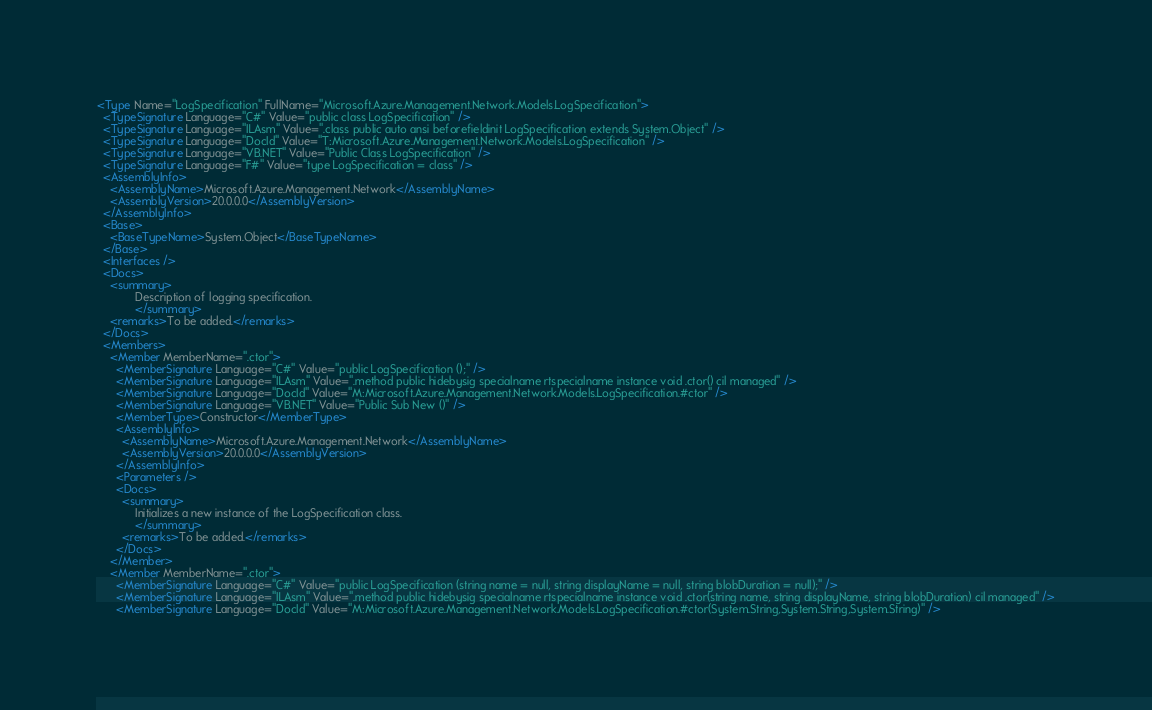<code> <loc_0><loc_0><loc_500><loc_500><_XML_><Type Name="LogSpecification" FullName="Microsoft.Azure.Management.Network.Models.LogSpecification">
  <TypeSignature Language="C#" Value="public class LogSpecification" />
  <TypeSignature Language="ILAsm" Value=".class public auto ansi beforefieldinit LogSpecification extends System.Object" />
  <TypeSignature Language="DocId" Value="T:Microsoft.Azure.Management.Network.Models.LogSpecification" />
  <TypeSignature Language="VB.NET" Value="Public Class LogSpecification" />
  <TypeSignature Language="F#" Value="type LogSpecification = class" />
  <AssemblyInfo>
    <AssemblyName>Microsoft.Azure.Management.Network</AssemblyName>
    <AssemblyVersion>20.0.0.0</AssemblyVersion>
  </AssemblyInfo>
  <Base>
    <BaseTypeName>System.Object</BaseTypeName>
  </Base>
  <Interfaces />
  <Docs>
    <summary>
            Description of logging specification.
            </summary>
    <remarks>To be added.</remarks>
  </Docs>
  <Members>
    <Member MemberName=".ctor">
      <MemberSignature Language="C#" Value="public LogSpecification ();" />
      <MemberSignature Language="ILAsm" Value=".method public hidebysig specialname rtspecialname instance void .ctor() cil managed" />
      <MemberSignature Language="DocId" Value="M:Microsoft.Azure.Management.Network.Models.LogSpecification.#ctor" />
      <MemberSignature Language="VB.NET" Value="Public Sub New ()" />
      <MemberType>Constructor</MemberType>
      <AssemblyInfo>
        <AssemblyName>Microsoft.Azure.Management.Network</AssemblyName>
        <AssemblyVersion>20.0.0.0</AssemblyVersion>
      </AssemblyInfo>
      <Parameters />
      <Docs>
        <summary>
            Initializes a new instance of the LogSpecification class.
            </summary>
        <remarks>To be added.</remarks>
      </Docs>
    </Member>
    <Member MemberName=".ctor">
      <MemberSignature Language="C#" Value="public LogSpecification (string name = null, string displayName = null, string blobDuration = null);" />
      <MemberSignature Language="ILAsm" Value=".method public hidebysig specialname rtspecialname instance void .ctor(string name, string displayName, string blobDuration) cil managed" />
      <MemberSignature Language="DocId" Value="M:Microsoft.Azure.Management.Network.Models.LogSpecification.#ctor(System.String,System.String,System.String)" /></code> 